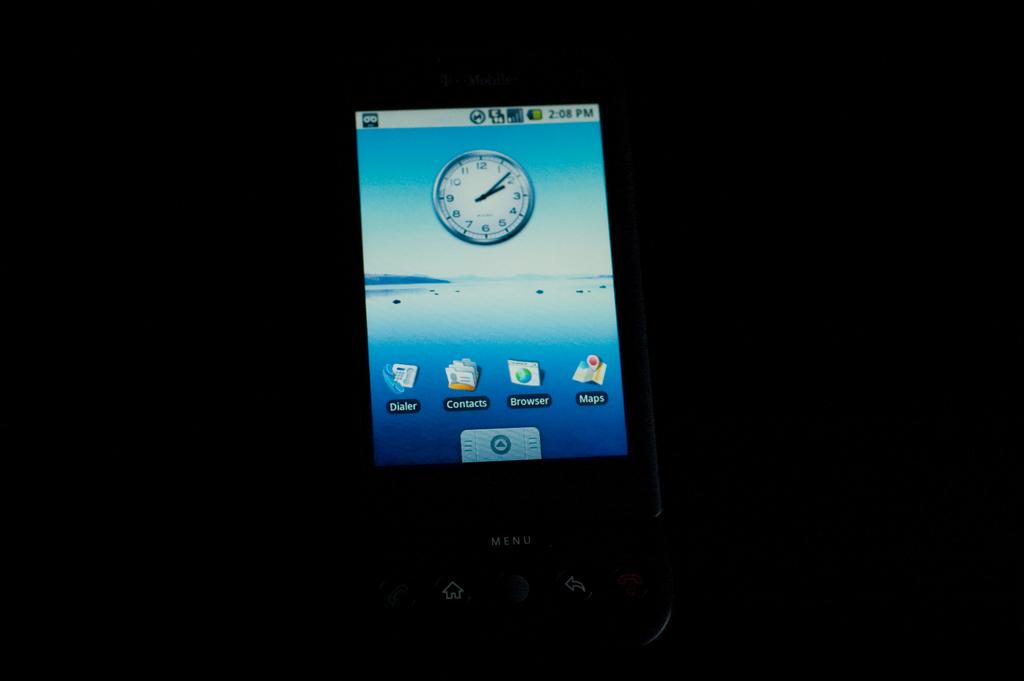Where is the contacts button?
Provide a short and direct response. Second at the bottom. What time is it on the phone?
Make the answer very short. 2:08. 